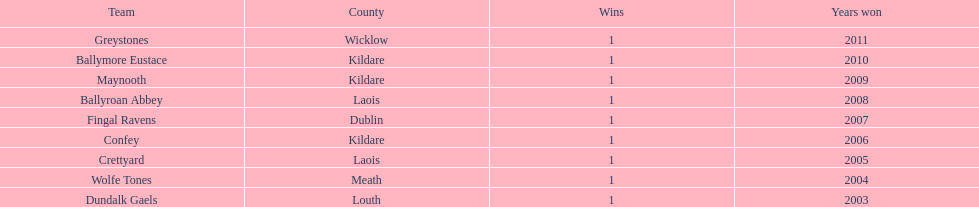What county does the team that claimed victory in 2009 originate from? Kildare. What is the name of this team? Maynooth. 